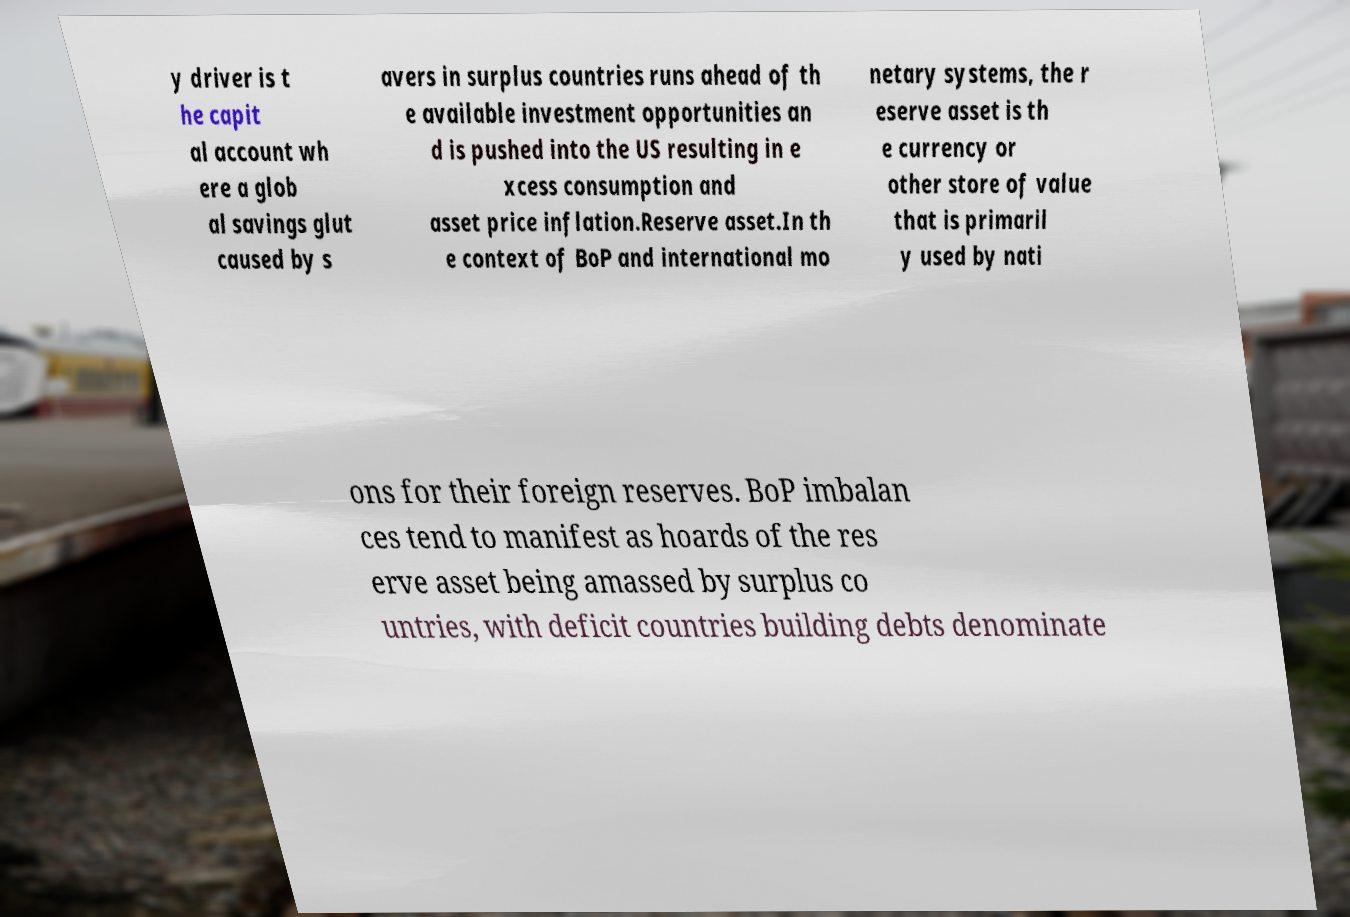I need the written content from this picture converted into text. Can you do that? y driver is t he capit al account wh ere a glob al savings glut caused by s avers in surplus countries runs ahead of th e available investment opportunities an d is pushed into the US resulting in e xcess consumption and asset price inflation.Reserve asset.In th e context of BoP and international mo netary systems, the r eserve asset is th e currency or other store of value that is primaril y used by nati ons for their foreign reserves. BoP imbalan ces tend to manifest as hoards of the res erve asset being amassed by surplus co untries, with deficit countries building debts denominate 